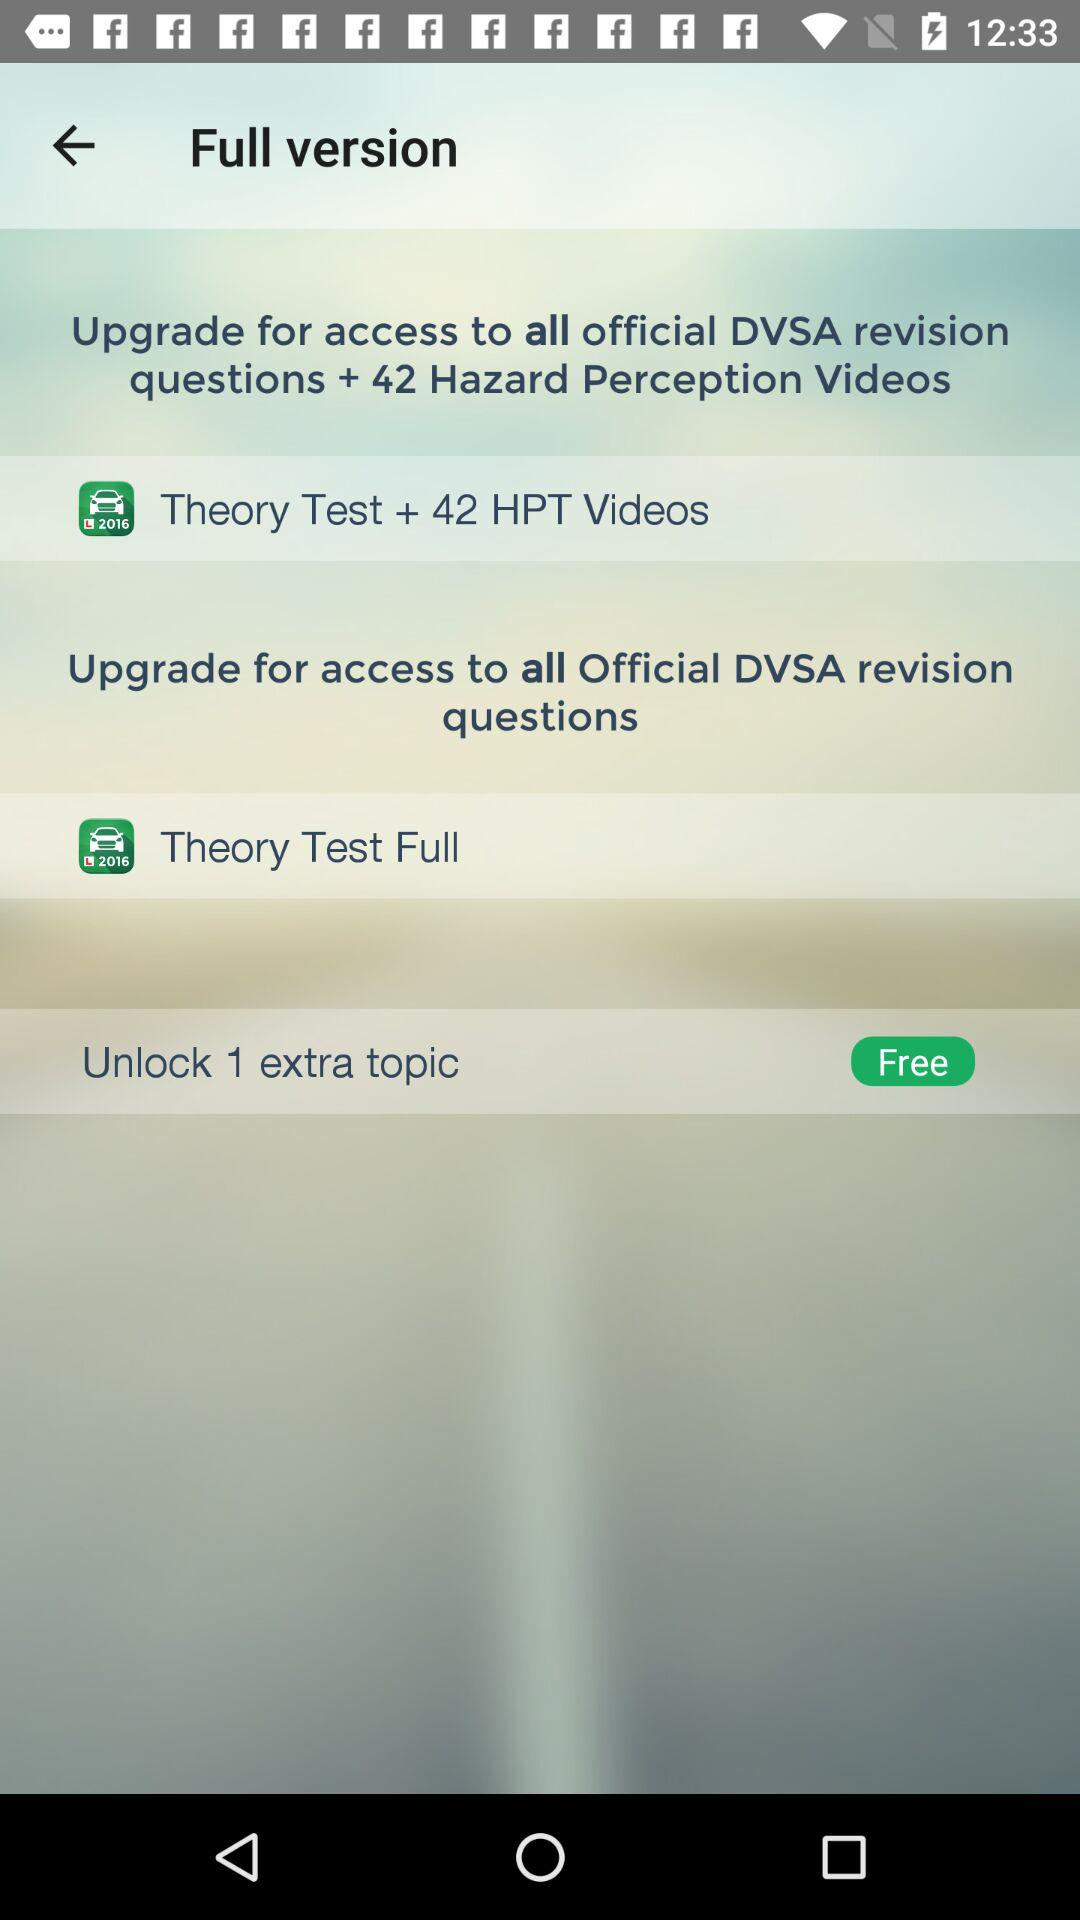How many extra topics are free to unlock? There is 1 extra topic that is free to unlock. 